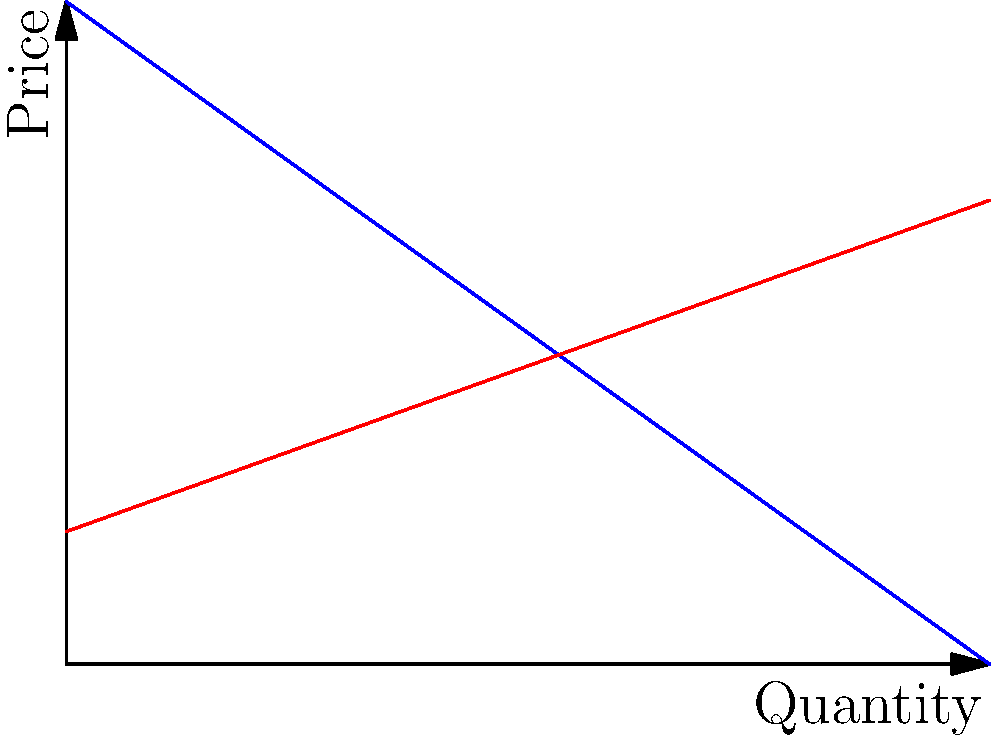A budget fashion line is considering launching a new product. The demand curve for this product is given by $P = 100 - 0.5Q$, where $P$ is the price in dollars and $Q$ is the quantity demanded. The supply curve is given by $P = 20 + 0.25Q$. What quantity should be produced to maximize profit, and what will be the corresponding price and maximum profit? Let's approach this step-by-step:

1) First, we need to find the equilibrium point where supply equals demand:
   $100 - 0.5Q = 20 + 0.25Q$
   $80 = 0.75Q$
   $Q = 80$ units

2) The equilibrium price can be found by substituting $Q = 80$ into either equation:
   $P = 100 - 0.5(80) = 60$ dollars

3) To maximize profit, we need to find the producer surplus. This is the area above the supply curve and below the equilibrium price.

4) The producer surplus is a trapezoid. We can calculate its area:
   Area = $\frac{1}{2}(b_1 + b_2)h$
   where $b_1 = 60 - 20 = 40$ (price difference at $Q = 0$)
   $b_2 = 60 - 40 = 20$ (price difference at $Q = 80$)
   $h = 80$ (quantity)

5) Calculating the area:
   Profit = $\frac{1}{2}(40 + 20) * 80 = 2400$ dollars

Therefore, to maximize profit, the company should produce 80 units at a price of $60 each, resulting in a maximum profit of $2400.
Answer: 80 units; $60 per unit; $2400 profit 